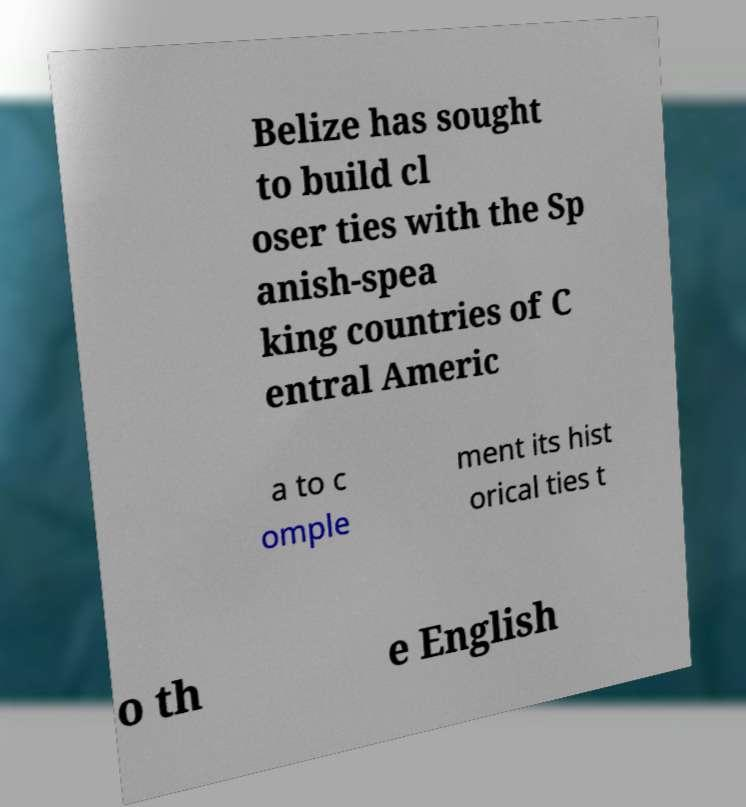Could you extract and type out the text from this image? Belize has sought to build cl oser ties with the Sp anish-spea king countries of C entral Americ a to c omple ment its hist orical ties t o th e English 